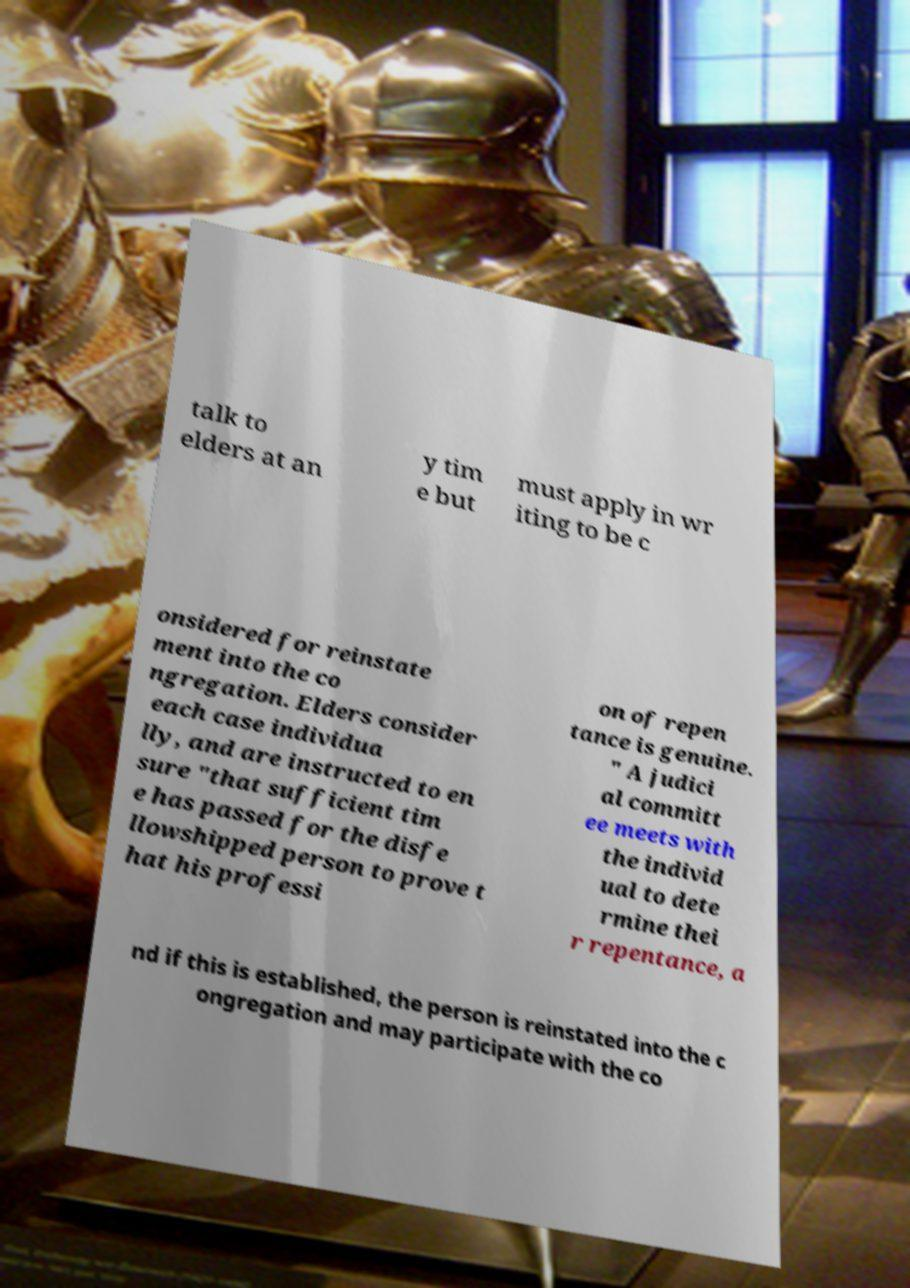Please identify and transcribe the text found in this image. talk to elders at an y tim e but must apply in wr iting to be c onsidered for reinstate ment into the co ngregation. Elders consider each case individua lly, and are instructed to en sure "that sufficient tim e has passed for the disfe llowshipped person to prove t hat his professi on of repen tance is genuine. " A judici al committ ee meets with the individ ual to dete rmine thei r repentance, a nd if this is established, the person is reinstated into the c ongregation and may participate with the co 